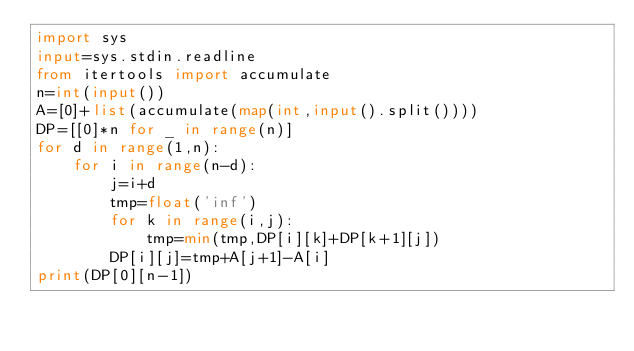<code> <loc_0><loc_0><loc_500><loc_500><_Python_>import sys
input=sys.stdin.readline
from itertools import accumulate
n=int(input())
A=[0]+list(accumulate(map(int,input().split())))
DP=[[0]*n for _ in range(n)]
for d in range(1,n):
    for i in range(n-d):
        j=i+d
        tmp=float('inf')
        for k in range(i,j):
            tmp=min(tmp,DP[i][k]+DP[k+1][j])
        DP[i][j]=tmp+A[j+1]-A[i]
print(DP[0][n-1])</code> 